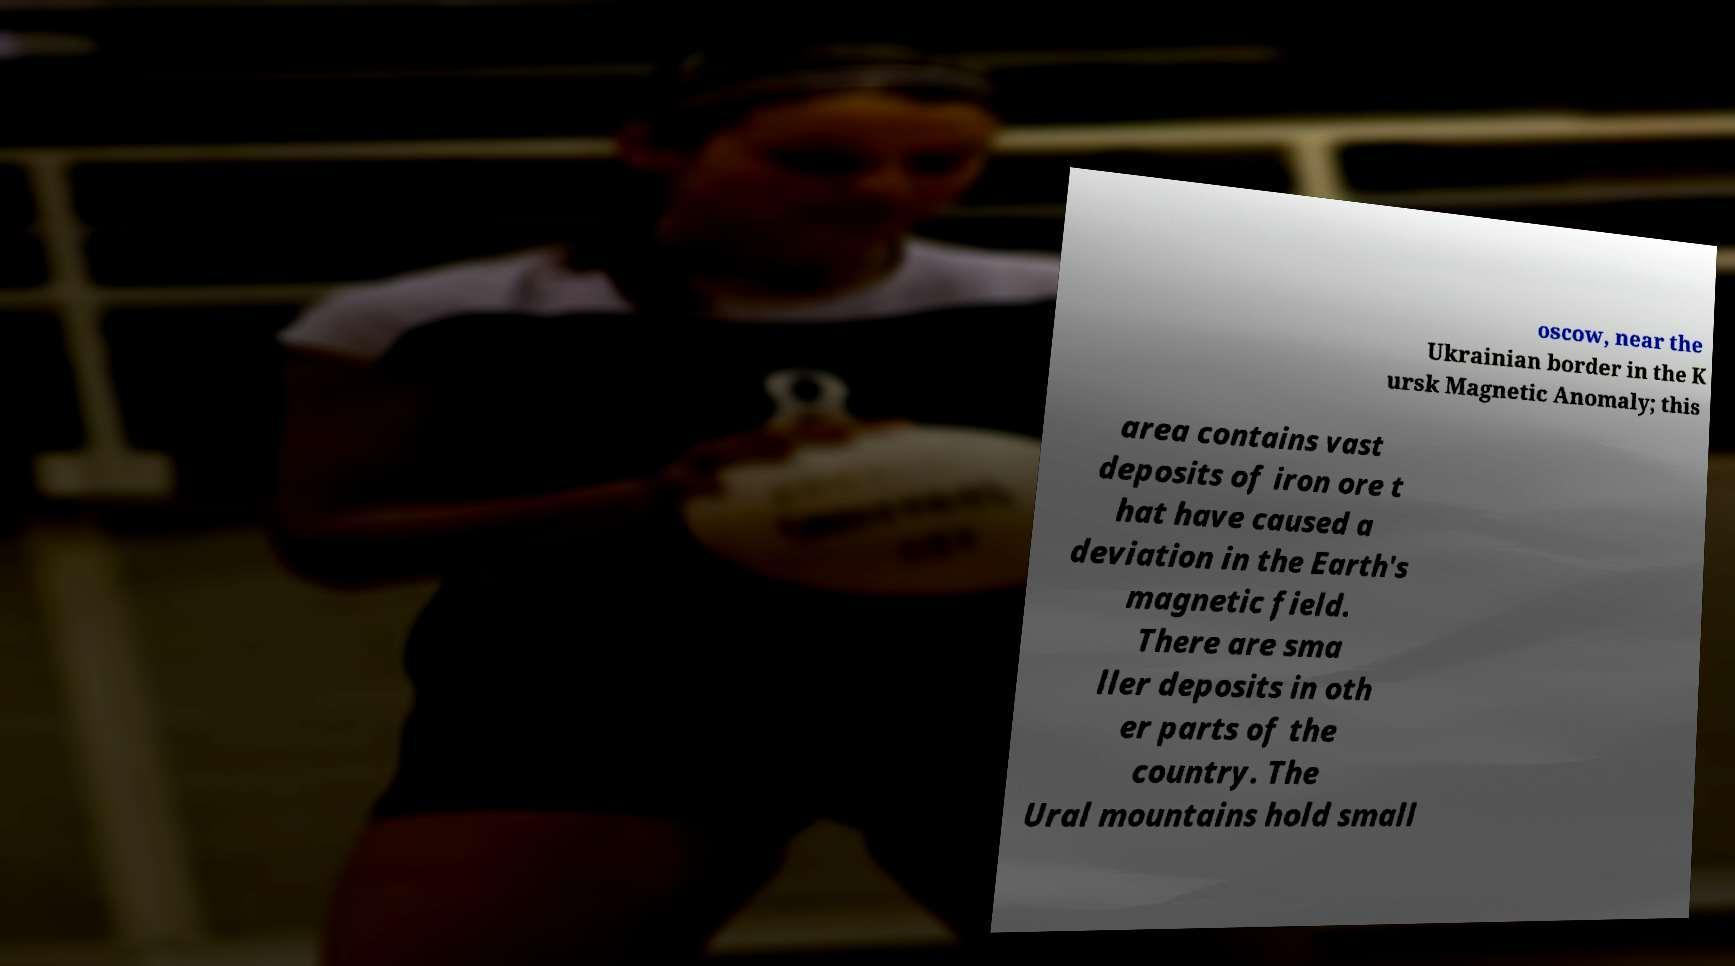Please read and relay the text visible in this image. What does it say? oscow, near the Ukrainian border in the K ursk Magnetic Anomaly; this area contains vast deposits of iron ore t hat have caused a deviation in the Earth's magnetic field. There are sma ller deposits in oth er parts of the country. The Ural mountains hold small 